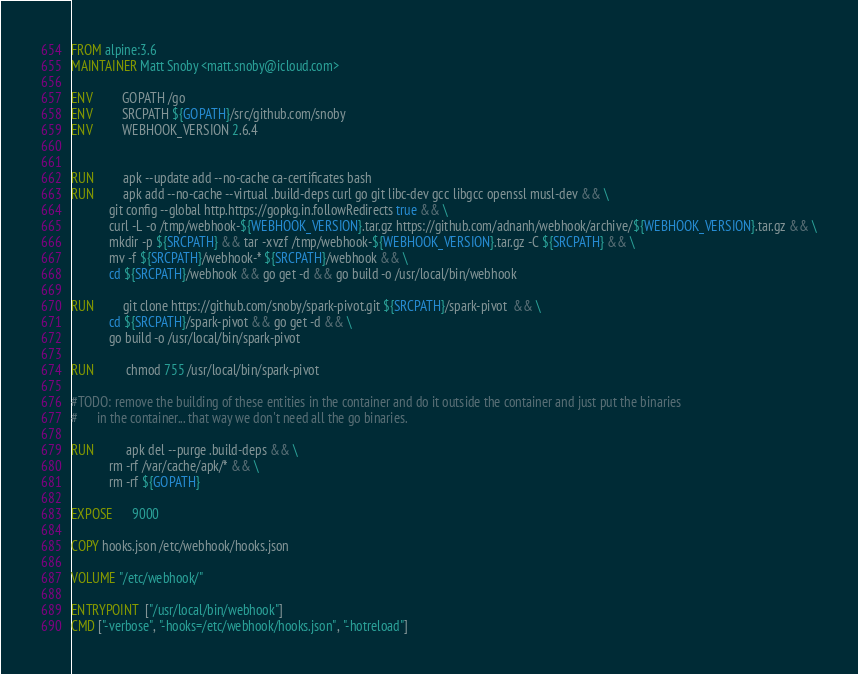Convert code to text. <code><loc_0><loc_0><loc_500><loc_500><_Dockerfile_>FROM alpine:3.6
MAINTAINER Matt Snoby <matt.snoby@icloud.com>

ENV         GOPATH /go
ENV         SRCPATH ${GOPATH}/src/github.com/snoby
ENV         WEBHOOK_VERSION 2.6.4


RUN         apk --update add --no-cache ca-certificates bash
RUN         apk add --no-cache --virtual .build-deps curl go git libc-dev gcc libgcc openssl musl-dev && \
            git config --global http.https://gopkg.in.followRedirects true && \
            curl -L -o /tmp/webhook-${WEBHOOK_VERSION}.tar.gz https://github.com/adnanh/webhook/archive/${WEBHOOK_VERSION}.tar.gz && \
            mkdir -p ${SRCPATH} && tar -xvzf /tmp/webhook-${WEBHOOK_VERSION}.tar.gz -C ${SRCPATH} && \
            mv -f ${SRCPATH}/webhook-* ${SRCPATH}/webhook && \
            cd ${SRCPATH}/webhook && go get -d && go build -o /usr/local/bin/webhook

RUN         git clone https://github.com/snoby/spark-pivot.git ${SRCPATH}/spark-pivot  && \
            cd ${SRCPATH}/spark-pivot && go get -d && \
            go build -o /usr/local/bin/spark-pivot

RUN          chmod 755 /usr/local/bin/spark-pivot

#TODO: remove the building of these entities in the container and do it outside the container and just put the binaries
#      in the container... that way we don't need all the go binaries.

RUN          apk del --purge .build-deps && \
            rm -rf /var/cache/apk/* && \
            rm -rf ${GOPATH}

EXPOSE      9000

COPY hooks.json /etc/webhook/hooks.json

VOLUME "/etc/webhook/"

ENTRYPOINT  ["/usr/local/bin/webhook"]
CMD ["-verbose", "-hooks=/etc/webhook/hooks.json", "-hotreload"]
</code> 